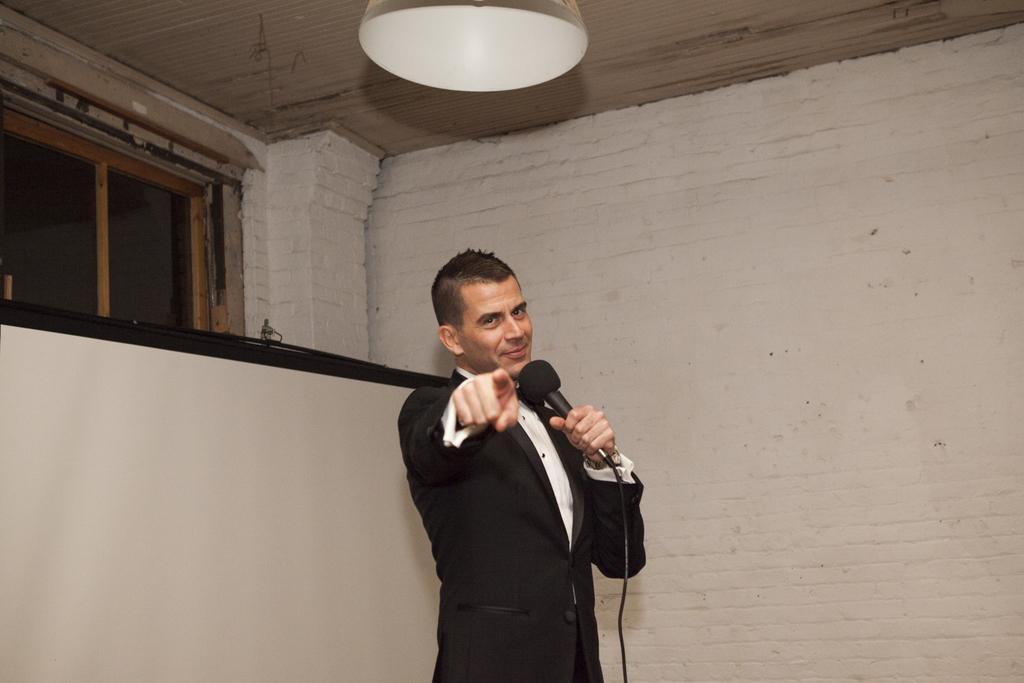Can you describe this image briefly? This picture shows a man standing with a smile on his face and holding a microphone in his hand and we see a projector screen back of him 